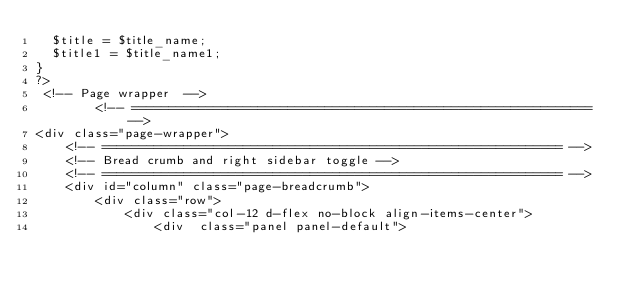<code> <loc_0><loc_0><loc_500><loc_500><_PHP_>	$title = $title_name;
	$title1 = $title_name1;
}
?>
 <!-- Page wrapper  -->
        <!-- ============================================================== -->
<div class="page-wrapper">
    <!-- ============================================================== -->
    <!-- Bread crumb and right sidebar toggle -->
    <!-- ============================================================== -->
    <div id="column" class="page-breadcrumb">
        <div class="row">
            <div class="col-12 d-flex no-block align-items-center">
                <div  class="panel panel-default">			</code> 